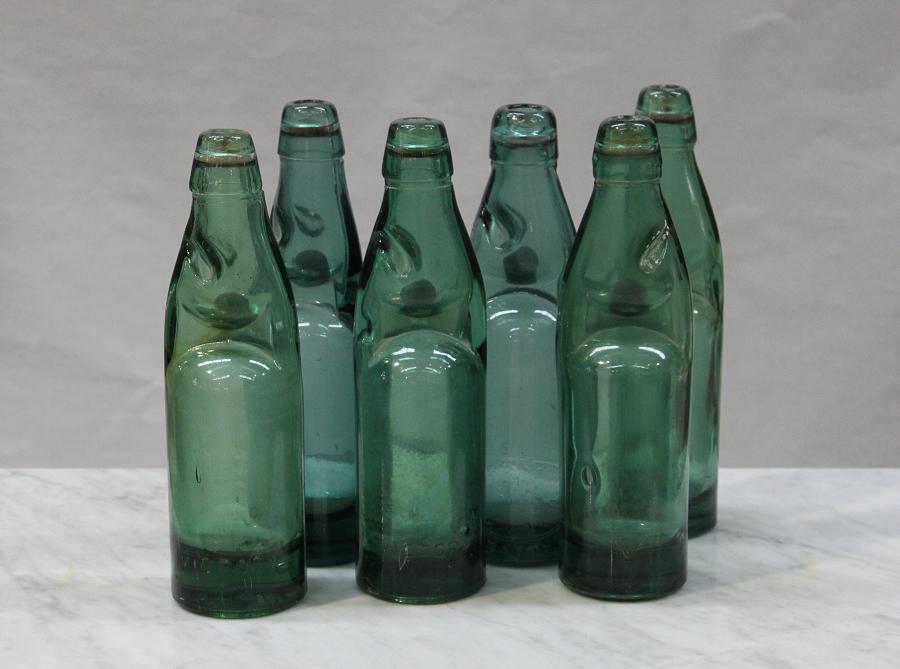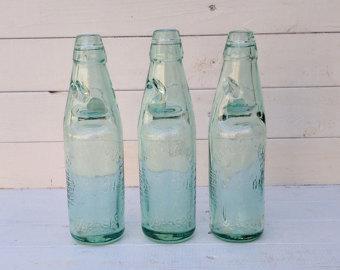The first image is the image on the left, the second image is the image on the right. Assess this claim about the two images: "One of the bottles is filled with red liquid.". Correct or not? Answer yes or no. No. The first image is the image on the left, the second image is the image on the right. Examine the images to the left and right. Is the description "There are no more than three bottles in the right image." accurate? Answer yes or no. Yes. 